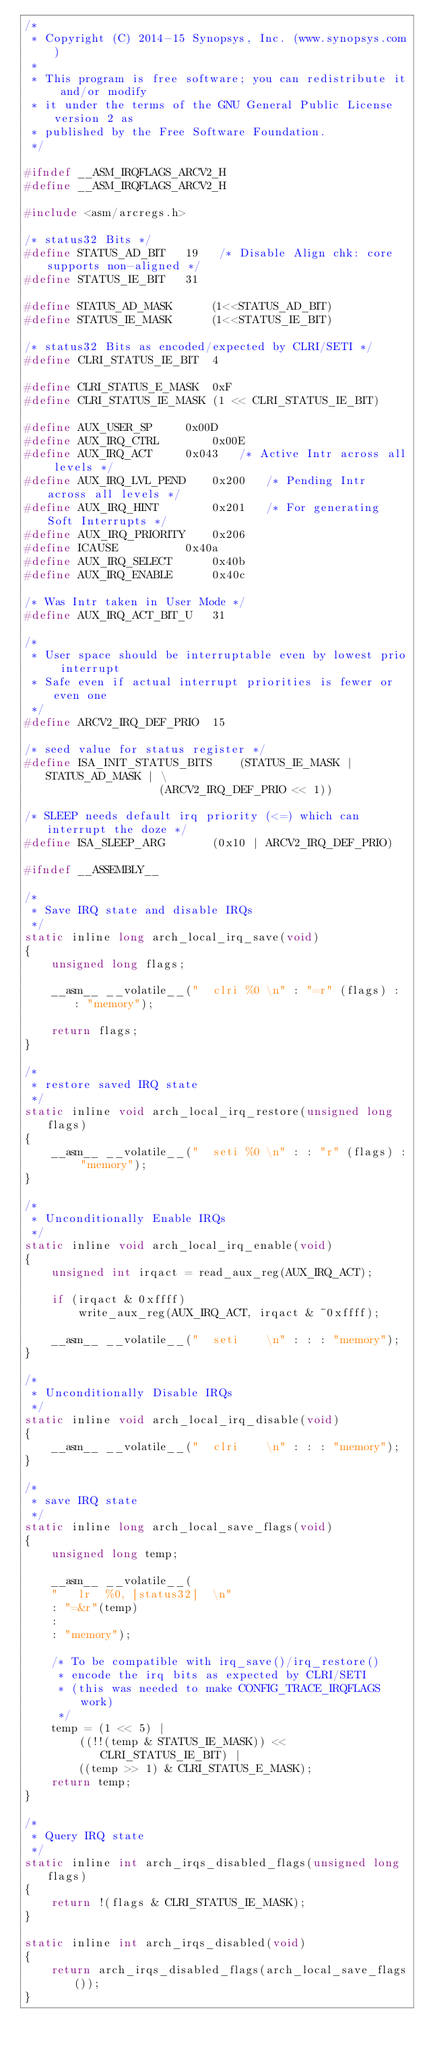Convert code to text. <code><loc_0><loc_0><loc_500><loc_500><_C_>/*
 * Copyright (C) 2014-15 Synopsys, Inc. (www.synopsys.com)
 *
 * This program is free software; you can redistribute it and/or modify
 * it under the terms of the GNU General Public License version 2 as
 * published by the Free Software Foundation.
 */

#ifndef __ASM_IRQFLAGS_ARCV2_H
#define __ASM_IRQFLAGS_ARCV2_H

#include <asm/arcregs.h>

/* status32 Bits */
#define STATUS_AD_BIT	19   /* Disable Align chk: core supports non-aligned */
#define STATUS_IE_BIT	31

#define STATUS_AD_MASK		(1<<STATUS_AD_BIT)
#define STATUS_IE_MASK		(1<<STATUS_IE_BIT)

/* status32 Bits as encoded/expected by CLRI/SETI */
#define CLRI_STATUS_IE_BIT	4

#define CLRI_STATUS_E_MASK	0xF
#define CLRI_STATUS_IE_MASK	(1 << CLRI_STATUS_IE_BIT)

#define AUX_USER_SP		0x00D
#define AUX_IRQ_CTRL		0x00E
#define AUX_IRQ_ACT		0x043	/* Active Intr across all levels */
#define AUX_IRQ_LVL_PEND	0x200	/* Pending Intr across all levels */
#define AUX_IRQ_HINT		0x201	/* For generating Soft Interrupts */
#define AUX_IRQ_PRIORITY	0x206
#define ICAUSE			0x40a
#define AUX_IRQ_SELECT		0x40b
#define AUX_IRQ_ENABLE		0x40c

/* Was Intr taken in User Mode */
#define AUX_IRQ_ACT_BIT_U	31

/*
 * User space should be interruptable even by lowest prio interrupt
 * Safe even if actual interrupt priorities is fewer or even one
 */
#define ARCV2_IRQ_DEF_PRIO	15

/* seed value for status register */
#define ISA_INIT_STATUS_BITS	(STATUS_IE_MASK | STATUS_AD_MASK | \
					(ARCV2_IRQ_DEF_PRIO << 1))

/* SLEEP needs default irq priority (<=) which can interrupt the doze */
#define ISA_SLEEP_ARG		(0x10 | ARCV2_IRQ_DEF_PRIO)

#ifndef __ASSEMBLY__

/*
 * Save IRQ state and disable IRQs
 */
static inline long arch_local_irq_save(void)
{
	unsigned long flags;

	__asm__ __volatile__("	clri %0	\n" : "=r" (flags) : : "memory");

	return flags;
}

/*
 * restore saved IRQ state
 */
static inline void arch_local_irq_restore(unsigned long flags)
{
	__asm__ __volatile__("	seti %0	\n" : : "r" (flags) : "memory");
}

/*
 * Unconditionally Enable IRQs
 */
static inline void arch_local_irq_enable(void)
{
	unsigned int irqact = read_aux_reg(AUX_IRQ_ACT);

	if (irqact & 0xffff)
		write_aux_reg(AUX_IRQ_ACT, irqact & ~0xffff);

	__asm__ __volatile__("	seti	\n" : : : "memory");
}

/*
 * Unconditionally Disable IRQs
 */
static inline void arch_local_irq_disable(void)
{
	__asm__ __volatile__("	clri	\n" : : : "memory");
}

/*
 * save IRQ state
 */
static inline long arch_local_save_flags(void)
{
	unsigned long temp;

	__asm__ __volatile__(
	"	lr  %0, [status32]	\n"
	: "=&r"(temp)
	:
	: "memory");

	/* To be compatible with irq_save()/irq_restore()
	 * encode the irq bits as expected by CLRI/SETI
	 * (this was needed to make CONFIG_TRACE_IRQFLAGS work)
	 */
	temp = (1 << 5) |
		((!!(temp & STATUS_IE_MASK)) << CLRI_STATUS_IE_BIT) |
		((temp >> 1) & CLRI_STATUS_E_MASK);
	return temp;
}

/*
 * Query IRQ state
 */
static inline int arch_irqs_disabled_flags(unsigned long flags)
{
	return !(flags & CLRI_STATUS_IE_MASK);
}

static inline int arch_irqs_disabled(void)
{
	return arch_irqs_disabled_flags(arch_local_save_flags());
}
</code> 